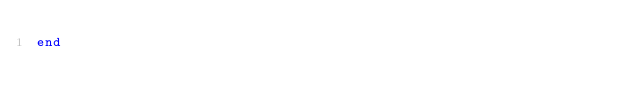Convert code to text. <code><loc_0><loc_0><loc_500><loc_500><_Julia_>end
</code> 